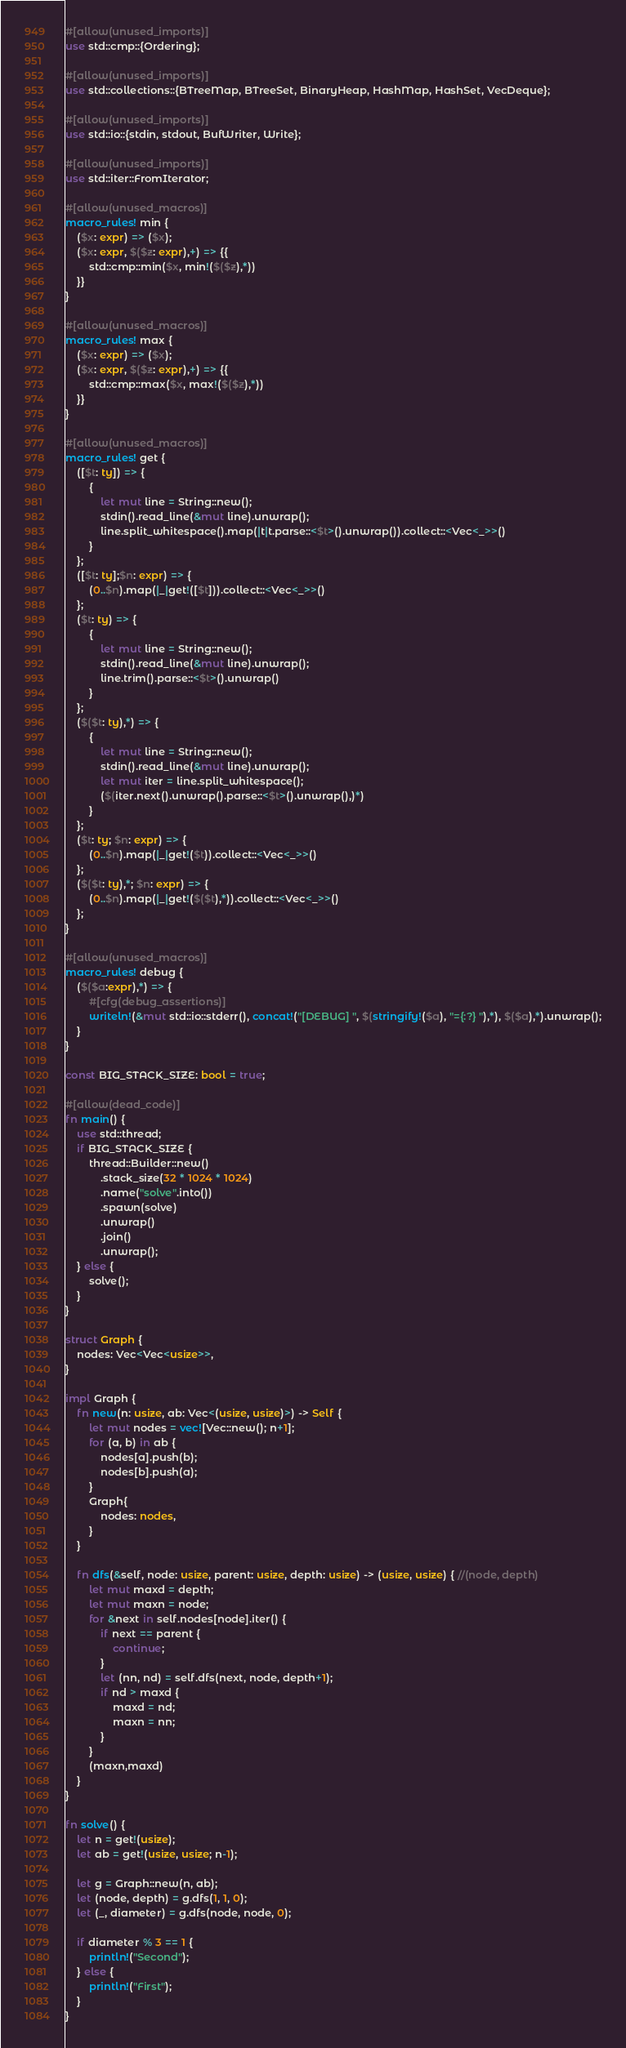<code> <loc_0><loc_0><loc_500><loc_500><_Rust_>#[allow(unused_imports)]
use std::cmp::{Ordering};

#[allow(unused_imports)]
use std::collections::{BTreeMap, BTreeSet, BinaryHeap, HashMap, HashSet, VecDeque};

#[allow(unused_imports)]
use std::io::{stdin, stdout, BufWriter, Write};

#[allow(unused_imports)]
use std::iter::FromIterator;

#[allow(unused_macros)]
macro_rules! min {
    ($x: expr) => ($x);
    ($x: expr, $($z: expr),+) => {{
        std::cmp::min($x, min!($($z),*))
    }}
}

#[allow(unused_macros)]
macro_rules! max {
    ($x: expr) => ($x);
    ($x: expr, $($z: expr),+) => {{
        std::cmp::max($x, max!($($z),*))
    }}
}

#[allow(unused_macros)]
macro_rules! get { 
    ([$t: ty]) => { 
        { 
            let mut line = String::new(); 
            stdin().read_line(&mut line).unwrap(); 
            line.split_whitespace().map(|t|t.parse::<$t>().unwrap()).collect::<Vec<_>>()
        }
    };
    ([$t: ty];$n: expr) => {
        (0..$n).map(|_|get!([$t])).collect::<Vec<_>>()
    };
    ($t: ty) => {
        {
            let mut line = String::new();
            stdin().read_line(&mut line).unwrap();
            line.trim().parse::<$t>().unwrap()
        }
    };
    ($($t: ty),*) => {
        { 
            let mut line = String::new();
            stdin().read_line(&mut line).unwrap();
            let mut iter = line.split_whitespace();
            ($(iter.next().unwrap().parse::<$t>().unwrap(),)*)
        }
    };
    ($t: ty; $n: expr) => {
        (0..$n).map(|_|get!($t)).collect::<Vec<_>>()
    };
    ($($t: ty),*; $n: expr) => {
        (0..$n).map(|_|get!($($t),*)).collect::<Vec<_>>()
    };
}

#[allow(unused_macros)]
macro_rules! debug {
    ($($a:expr),*) => {
        #[cfg(debug_assertions)]
        writeln!(&mut std::io::stderr(), concat!("[DEBUG] ", $(stringify!($a), "={:?} "),*), $($a),*).unwrap();
    }
}

const BIG_STACK_SIZE: bool = true;

#[allow(dead_code)]
fn main() {
    use std::thread;
    if BIG_STACK_SIZE {
        thread::Builder::new()
            .stack_size(32 * 1024 * 1024)
            .name("solve".into())
            .spawn(solve)
            .unwrap()
            .join()
            .unwrap();
    } else {
        solve();
    }
}

struct Graph {
    nodes: Vec<Vec<usize>>,
}

impl Graph {
    fn new(n: usize, ab: Vec<(usize, usize)>) -> Self {
        let mut nodes = vec![Vec::new(); n+1];
        for (a, b) in ab {
            nodes[a].push(b);
            nodes[b].push(a);
        }
        Graph{
            nodes: nodes,
        }
    }

    fn dfs(&self, node: usize, parent: usize, depth: usize) -> (usize, usize) { //(node, depth)
        let mut maxd = depth;
        let mut maxn = node;
        for &next in self.nodes[node].iter() {
            if next == parent {
                continue;
            }
            let (nn, nd) = self.dfs(next, node, depth+1);
            if nd > maxd {
                maxd = nd;
                maxn = nn;
            }
        }
        (maxn,maxd)
    }
}

fn solve() {
    let n = get!(usize);
    let ab = get!(usize, usize; n-1);

    let g = Graph::new(n, ab);
    let (node, depth) = g.dfs(1, 1, 0);
    let (_, diameter) = g.dfs(node, node, 0);

    if diameter % 3 == 1 {
        println!("Second");
    } else {
        println!("First");
    }
}
</code> 